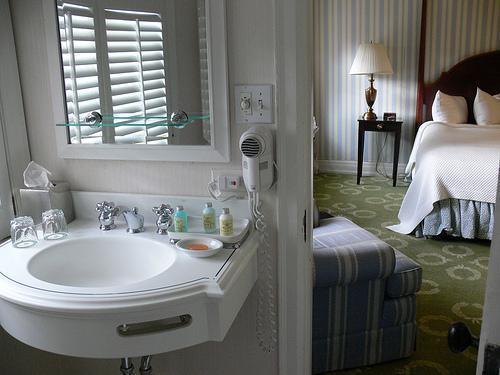How many beds are there?
Give a very brief answer. 1. 